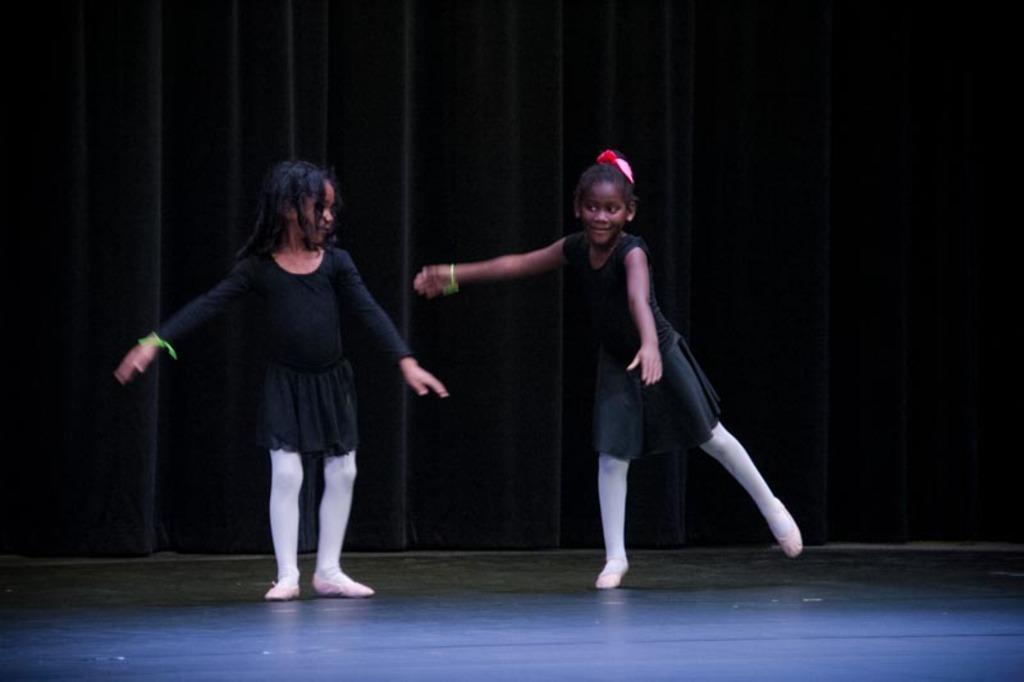In one or two sentences, can you explain what this image depicts? In the image we can see two girls wearing clothes, hand band and shoes, and they are dancing. Here we can see a floor and the curtains. 